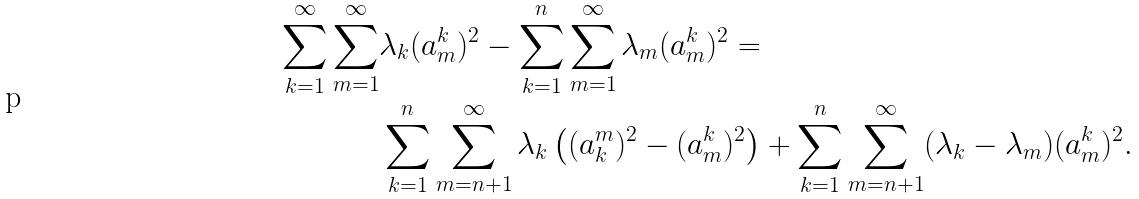Convert formula to latex. <formula><loc_0><loc_0><loc_500><loc_500>\sum _ { k = 1 } ^ { \infty } \sum _ { m = 1 } ^ { \infty } & \lambda _ { k } ( a ^ { k } _ { m } ) ^ { 2 } - \sum _ { k = 1 } ^ { n } \sum _ { m = 1 } ^ { \infty } \lambda _ { m } ( a ^ { k } _ { m } ) ^ { 2 } = \\ & \sum _ { k = 1 } ^ { n } \sum _ { m = n + 1 } ^ { \infty } \lambda _ { k } \left ( ( a ^ { m } _ { k } ) ^ { 2 } - ( a ^ { k } _ { m } ) ^ { 2 } \right ) + \sum _ { k = 1 } ^ { n } \sum _ { m = n + 1 } ^ { \infty } ( \lambda _ { k } - \lambda _ { m } ) ( a ^ { k } _ { m } ) ^ { 2 } .</formula> 